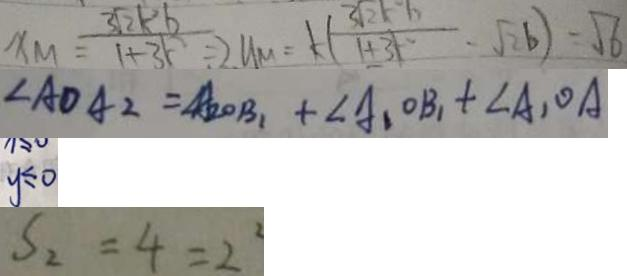Convert formula to latex. <formula><loc_0><loc_0><loc_500><loc_500>x _ { M } = \frac { 3 \sqrt { 2 } k ^ { 2 } b } { 1 + 3 k ^ { 2 } } = 2 y _ { m } = k ( \frac { 3 \sqrt { 2 } k ^ { 2 } b } { 1 + 3 k ^ { 2 } } - \sqrt { 2 } b ) = \sqrt { 6 } 
 \angle A D A _ { 2 } = \angle A _ { 2 } O B _ { 1 } + \angle A _ { 1 } O B + A _ { 1 } O A 
 y \leq 0 
 S _ { 2 } = 4 = 2 ^ { 2 }</formula> 